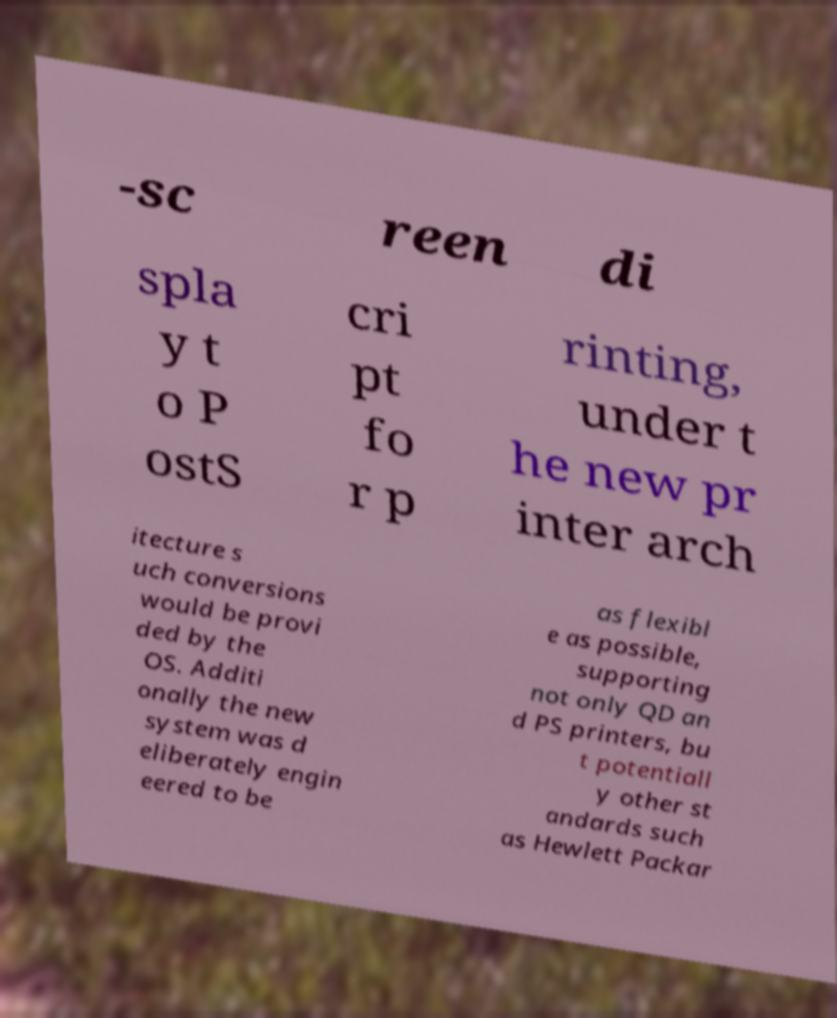Can you read and provide the text displayed in the image?This photo seems to have some interesting text. Can you extract and type it out for me? -sc reen di spla y t o P ostS cri pt fo r p rinting, under t he new pr inter arch itecture s uch conversions would be provi ded by the OS. Additi onally the new system was d eliberately engin eered to be as flexibl e as possible, supporting not only QD an d PS printers, bu t potentiall y other st andards such as Hewlett Packar 